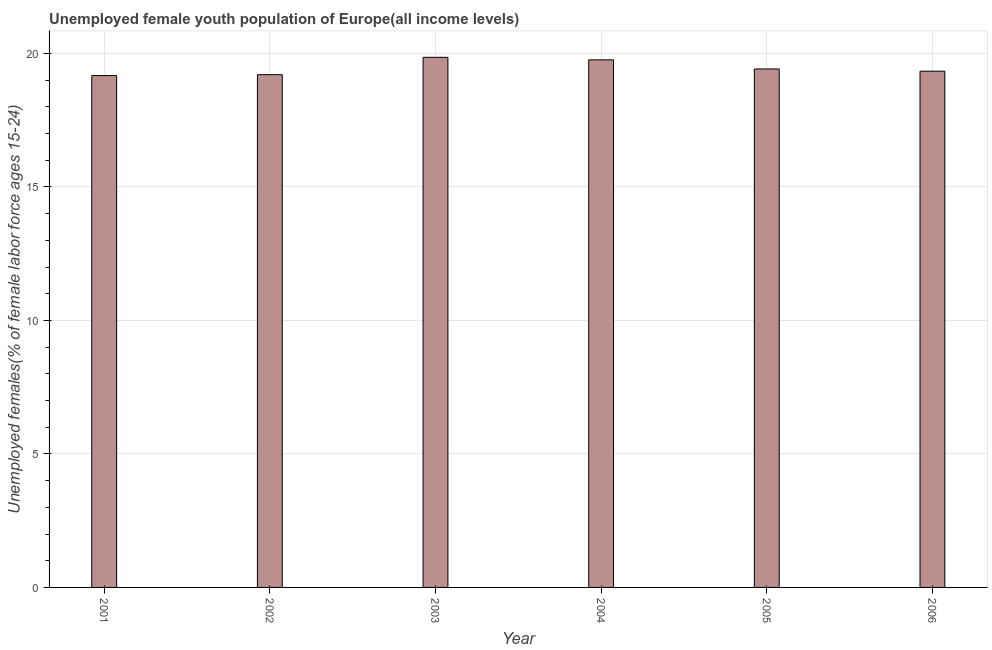Does the graph contain any zero values?
Offer a very short reply. No. What is the title of the graph?
Ensure brevity in your answer.  Unemployed female youth population of Europe(all income levels). What is the label or title of the X-axis?
Offer a very short reply. Year. What is the label or title of the Y-axis?
Provide a succinct answer. Unemployed females(% of female labor force ages 15-24). What is the unemployed female youth in 2005?
Your response must be concise. 19.42. Across all years, what is the maximum unemployed female youth?
Provide a short and direct response. 19.86. Across all years, what is the minimum unemployed female youth?
Give a very brief answer. 19.17. In which year was the unemployed female youth maximum?
Ensure brevity in your answer.  2003. In which year was the unemployed female youth minimum?
Offer a very short reply. 2001. What is the sum of the unemployed female youth?
Make the answer very short. 116.75. What is the difference between the unemployed female youth in 2001 and 2005?
Give a very brief answer. -0.25. What is the average unemployed female youth per year?
Give a very brief answer. 19.46. What is the median unemployed female youth?
Keep it short and to the point. 19.38. In how many years, is the unemployed female youth greater than 19 %?
Your answer should be compact. 6. What is the difference between the highest and the second highest unemployed female youth?
Provide a succinct answer. 0.09. What is the difference between the highest and the lowest unemployed female youth?
Make the answer very short. 0.68. In how many years, is the unemployed female youth greater than the average unemployed female youth taken over all years?
Provide a short and direct response. 2. How many bars are there?
Your response must be concise. 6. How many years are there in the graph?
Make the answer very short. 6. What is the difference between two consecutive major ticks on the Y-axis?
Provide a short and direct response. 5. What is the Unemployed females(% of female labor force ages 15-24) of 2001?
Make the answer very short. 19.17. What is the Unemployed females(% of female labor force ages 15-24) in 2002?
Offer a very short reply. 19.21. What is the Unemployed females(% of female labor force ages 15-24) in 2003?
Offer a terse response. 19.86. What is the Unemployed females(% of female labor force ages 15-24) in 2004?
Keep it short and to the point. 19.76. What is the Unemployed females(% of female labor force ages 15-24) of 2005?
Make the answer very short. 19.42. What is the Unemployed females(% of female labor force ages 15-24) of 2006?
Provide a short and direct response. 19.34. What is the difference between the Unemployed females(% of female labor force ages 15-24) in 2001 and 2002?
Your answer should be compact. -0.03. What is the difference between the Unemployed females(% of female labor force ages 15-24) in 2001 and 2003?
Make the answer very short. -0.68. What is the difference between the Unemployed females(% of female labor force ages 15-24) in 2001 and 2004?
Provide a short and direct response. -0.59. What is the difference between the Unemployed females(% of female labor force ages 15-24) in 2001 and 2005?
Keep it short and to the point. -0.25. What is the difference between the Unemployed females(% of female labor force ages 15-24) in 2001 and 2006?
Your answer should be compact. -0.16. What is the difference between the Unemployed females(% of female labor force ages 15-24) in 2002 and 2003?
Ensure brevity in your answer.  -0.65. What is the difference between the Unemployed females(% of female labor force ages 15-24) in 2002 and 2004?
Keep it short and to the point. -0.56. What is the difference between the Unemployed females(% of female labor force ages 15-24) in 2002 and 2005?
Offer a terse response. -0.21. What is the difference between the Unemployed females(% of female labor force ages 15-24) in 2002 and 2006?
Provide a succinct answer. -0.13. What is the difference between the Unemployed females(% of female labor force ages 15-24) in 2003 and 2004?
Provide a short and direct response. 0.09. What is the difference between the Unemployed females(% of female labor force ages 15-24) in 2003 and 2005?
Provide a succinct answer. 0.44. What is the difference between the Unemployed females(% of female labor force ages 15-24) in 2003 and 2006?
Ensure brevity in your answer.  0.52. What is the difference between the Unemployed females(% of female labor force ages 15-24) in 2004 and 2005?
Provide a succinct answer. 0.34. What is the difference between the Unemployed females(% of female labor force ages 15-24) in 2004 and 2006?
Give a very brief answer. 0.42. What is the difference between the Unemployed females(% of female labor force ages 15-24) in 2005 and 2006?
Provide a succinct answer. 0.08. What is the ratio of the Unemployed females(% of female labor force ages 15-24) in 2001 to that in 2003?
Provide a succinct answer. 0.97. What is the ratio of the Unemployed females(% of female labor force ages 15-24) in 2001 to that in 2004?
Provide a succinct answer. 0.97. What is the ratio of the Unemployed females(% of female labor force ages 15-24) in 2001 to that in 2005?
Your answer should be compact. 0.99. What is the ratio of the Unemployed females(% of female labor force ages 15-24) in 2002 to that in 2003?
Your answer should be compact. 0.97. What is the ratio of the Unemployed females(% of female labor force ages 15-24) in 2002 to that in 2005?
Keep it short and to the point. 0.99. What is the ratio of the Unemployed females(% of female labor force ages 15-24) in 2003 to that in 2004?
Your answer should be very brief. 1. What is the ratio of the Unemployed females(% of female labor force ages 15-24) in 2003 to that in 2005?
Your answer should be compact. 1.02. What is the ratio of the Unemployed females(% of female labor force ages 15-24) in 2004 to that in 2005?
Provide a short and direct response. 1.02. 